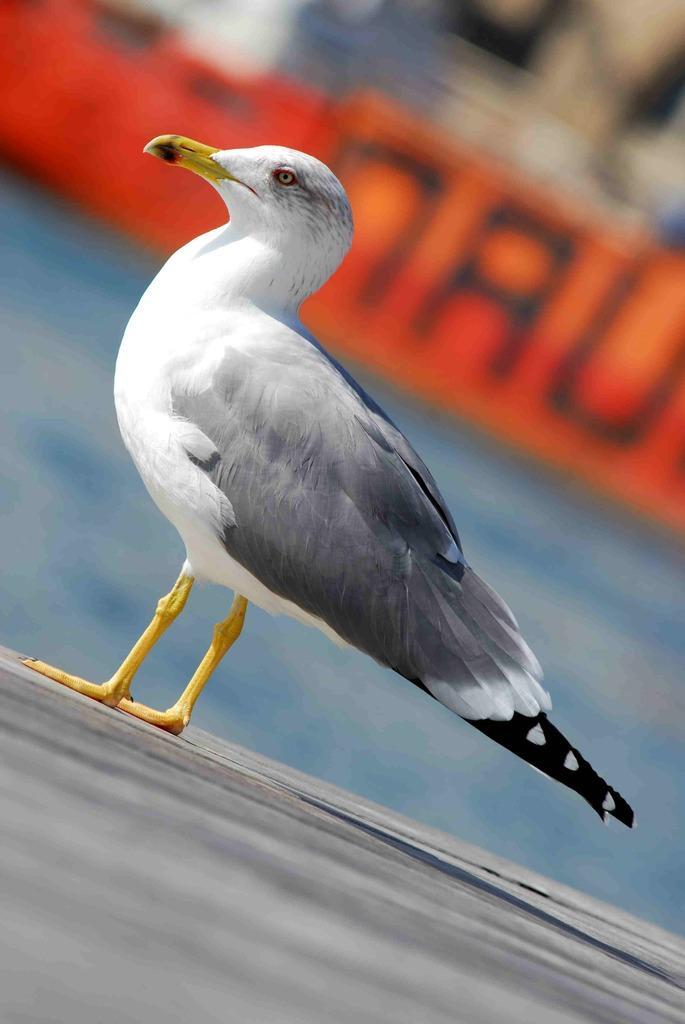Can you describe this image briefly? There is a European herring gull which is white and black in color is standing on an object and the background is in orange color. 